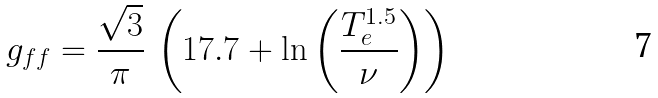Convert formula to latex. <formula><loc_0><loc_0><loc_500><loc_500>g _ { f f } = \frac { \sqrt { 3 } } { \pi } \, \left ( 1 7 . 7 + \ln \left ( \frac { T _ { e } ^ { 1 . 5 } } { \nu } \right ) \right )</formula> 